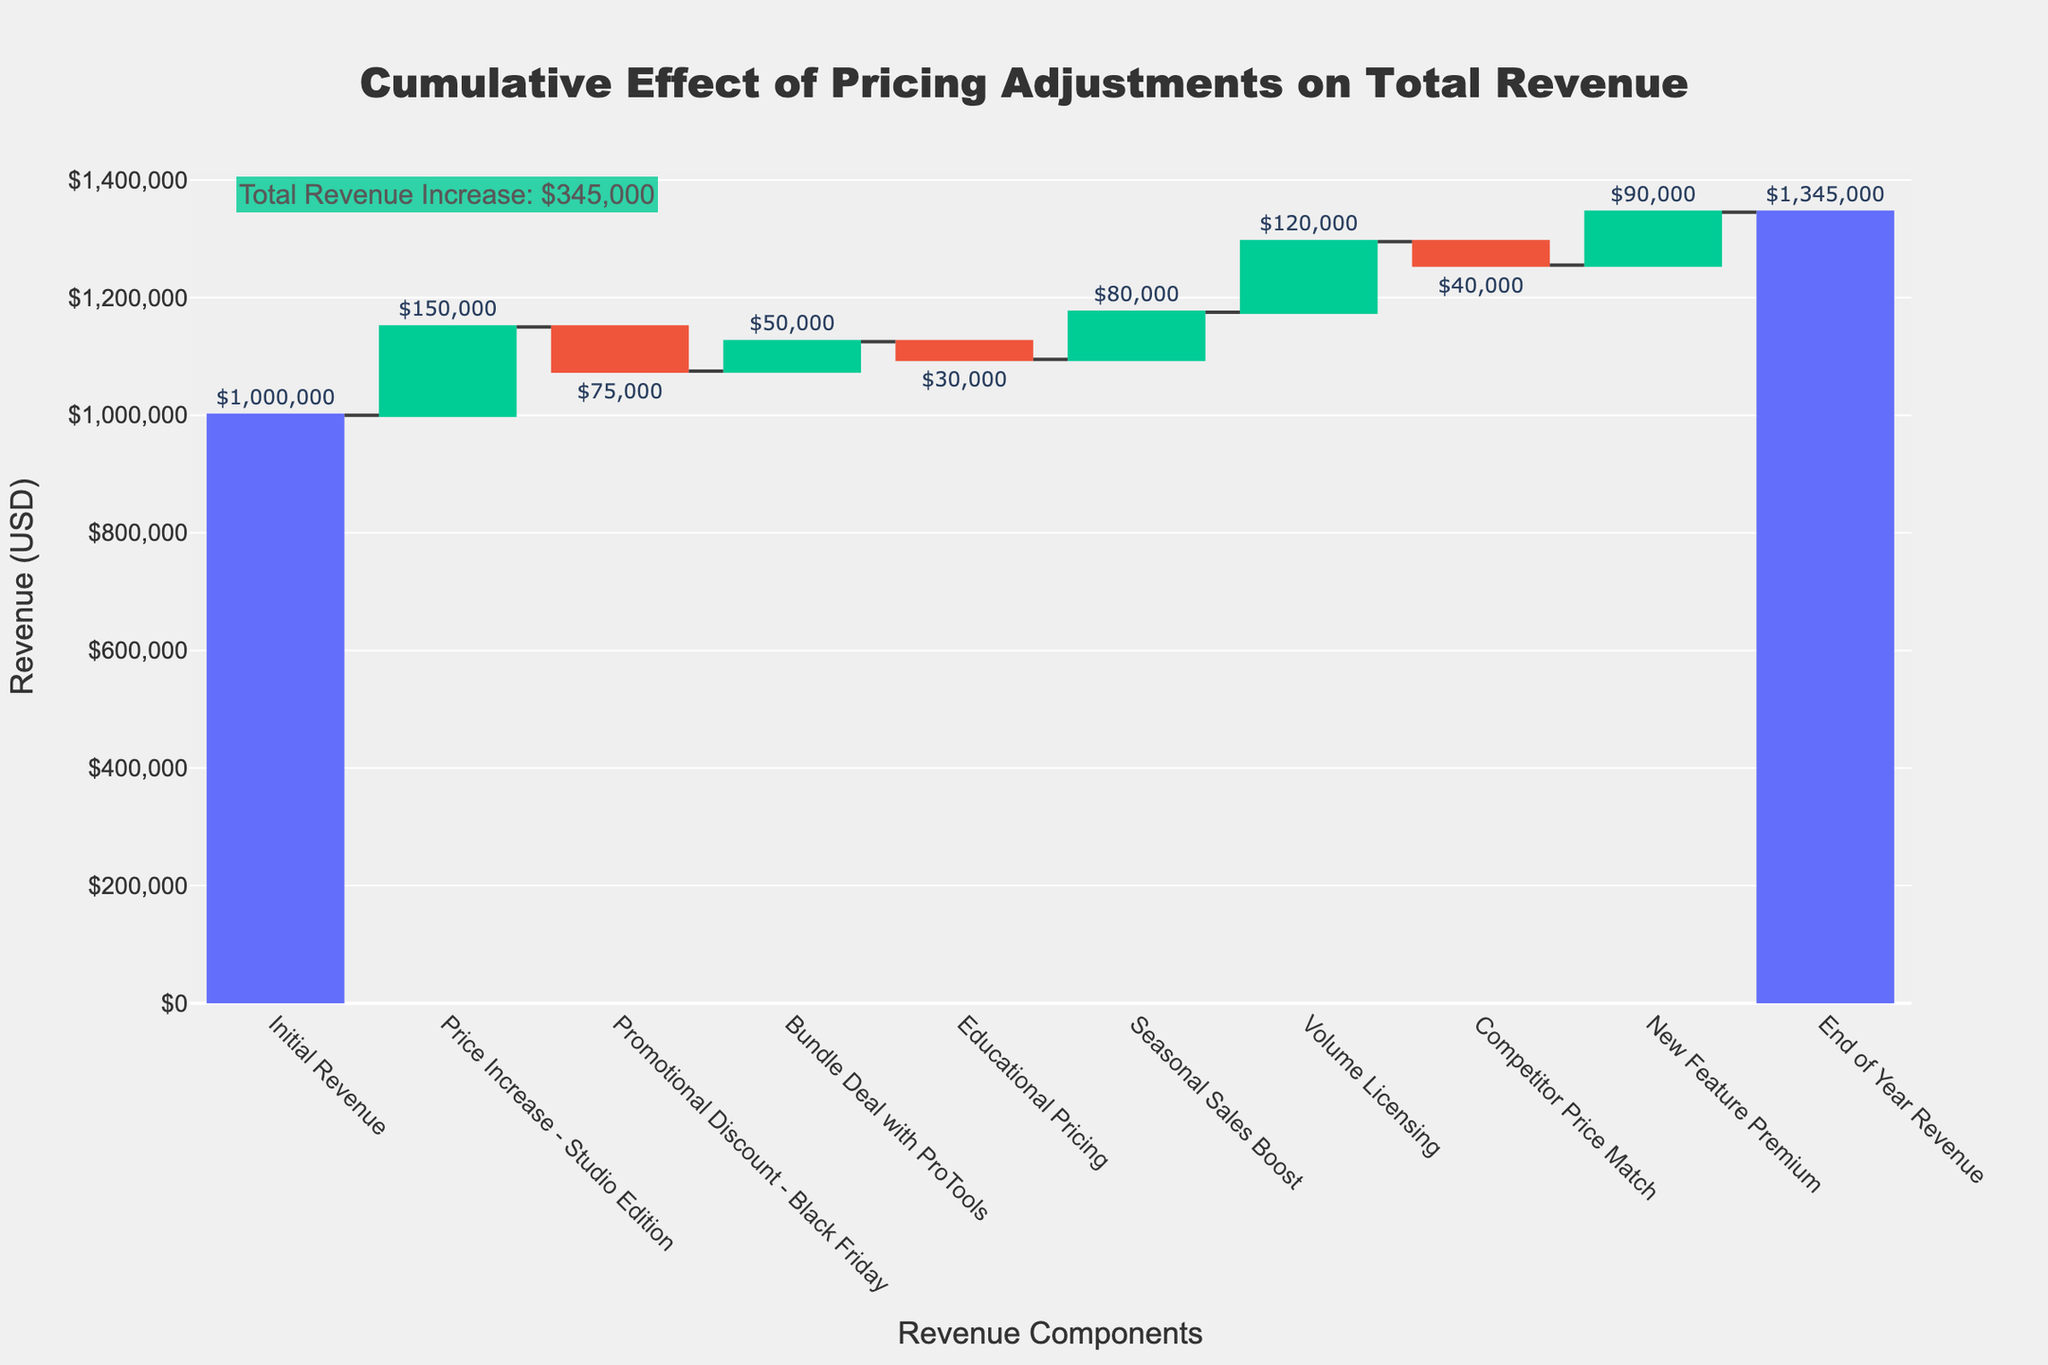What's the total revenue at the beginning? Look at the first column labeled "Initial Revenue" to find the initial revenue, which is $1,000,000.
Answer: $1,000,000 What is the cumulative increase in revenue from "Price Increase - Studio Edition" and "New Feature Premium"? Add the values of "Price Increase - Studio Edition" ($150,000) and "New Feature Premium" ($90,000), resulting in a total increase of $240,000.
Answer: $240,000 What's the total decrease in revenue from "Promotional Discount - Black Friday," "Educational Pricing," and "Competitor Price Match"? Sum the values of "Promotional Discount - Black Friday" (-$75,000), "Educational Pricing" (-$30,000), and "Competitor Price Match" (-$40,000), resulting in a total decrease of $145,000.
Answer: $145,000 Which category contributes the most to increasing revenue? The highest positive value among the categories is "Price Increase - Studio Edition" with an increase of $150,000.
Answer: Price Increase - Studio Edition How does the "Bundle Deal with ProTools" affect the revenue, compared to "Seasonal Sales Boost"? The "Bundle Deal with ProTools" increases revenue by $50,000, while "Seasonal Sales Boost" contributes an $80,000 increase. Comparing these, "Seasonal Sales Boost" has a larger positive effect.
Answer: Seasonal Sales Boost What’s the final revenue after all adjustments? Look at the last column labeled "End of Year Revenue," which indicates the total revenue after all adjustments, amounting to $1,345,000.
Answer: $1,345,000 What is the net effect of the pricing adjustments on total revenue? The net effect is the difference between the initial revenue ($1,000,000) and the end-of-year revenue ($1,345,000), which is an increase of $345,000.
Answer: $345,000 What's the impact of "Volume Licensing" on the revenue? Look at the column for "Volume Licensing," which shows that it increases revenue by $120,000.
Answer: $120,000 Does the "Educational Pricing" adjustment have a positive or negative effect on revenue? The "Educational Pricing" adjustment has a value of -$30,000, indicating a negative effect on revenue.
Answer: Negative What is the combined impact of "Promotional Discount - Black Friday" and "Competitor Price Match" on the revenue? Add the values of "Promotional Discount - Black Friday" (-$75,000) and "Competitor Price Match" (-$40,000), resulting in a total decrease of $115,000.
Answer: $115,000 